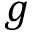Convert formula to latex. <formula><loc_0><loc_0><loc_500><loc_500>g</formula> 